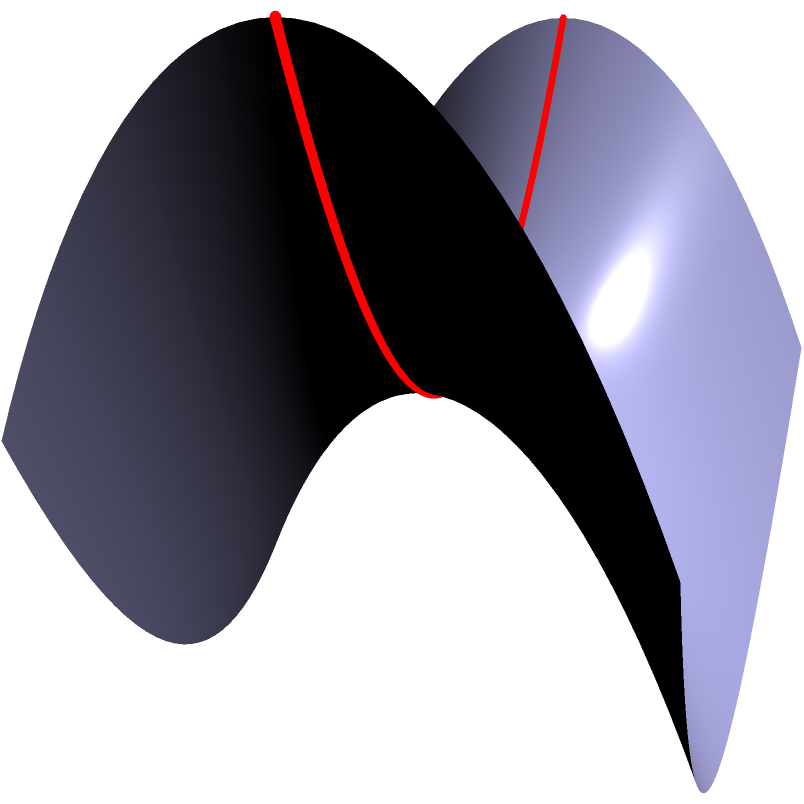As an investigative reporter, you've uncovered a secret terrorist communication method using non-Euclidean geometry. The message is encoded on a saddle-shaped surface. What is the most efficient path (geodesic) between two points on this surface, and how does it differ from a straight line in Euclidean space? To understand the geodesic on a saddle-shaped surface:

1. Surface equation: The saddle surface is described by $z = x^2 - y^2$.

2. Geodesics vs. Euclidean straight lines:
   a) In Euclidean space, the shortest path between two points is a straight line.
   b) On a curved surface, geodesics replace straight lines as the shortest paths.

3. Properties of geodesics on a saddle surface:
   a) They curve away from the center of the saddle.
   b) They follow the surface's curvature, minimizing the distance traveled.

4. Mathematical description:
   The geodesic equations for this surface are:
   $$\frac{d^2x}{dt^2} + 2x\left(\frac{dx}{dt}\right)^2 - 2x\left(\frac{dy}{dt}\right)^2 = 0$$
   $$\frac{d^2y}{dt^2} - 2y\left(\frac{dx}{dt}\right)^2 + 2y\left(\frac{dy}{dt}\right)^2 = 0$$

5. Visual representation:
   In the diagram, the red curve represents a geodesic on the saddle surface.
   Notice how it curves away from the center, following the surface's shape.

6. Difference from Euclidean straight line:
   If we were to draw a straight line between the same two points in Euclidean space, it would cut through the surface instead of following its curvature.

7. Implications for the encoded message:
   The terrorists are likely using the unique properties of geodesics on this surface to encode their messages, making them difficult to intercept and decode using traditional Euclidean methods.
Answer: Curved path following surface curvature, diverging from saddle center 